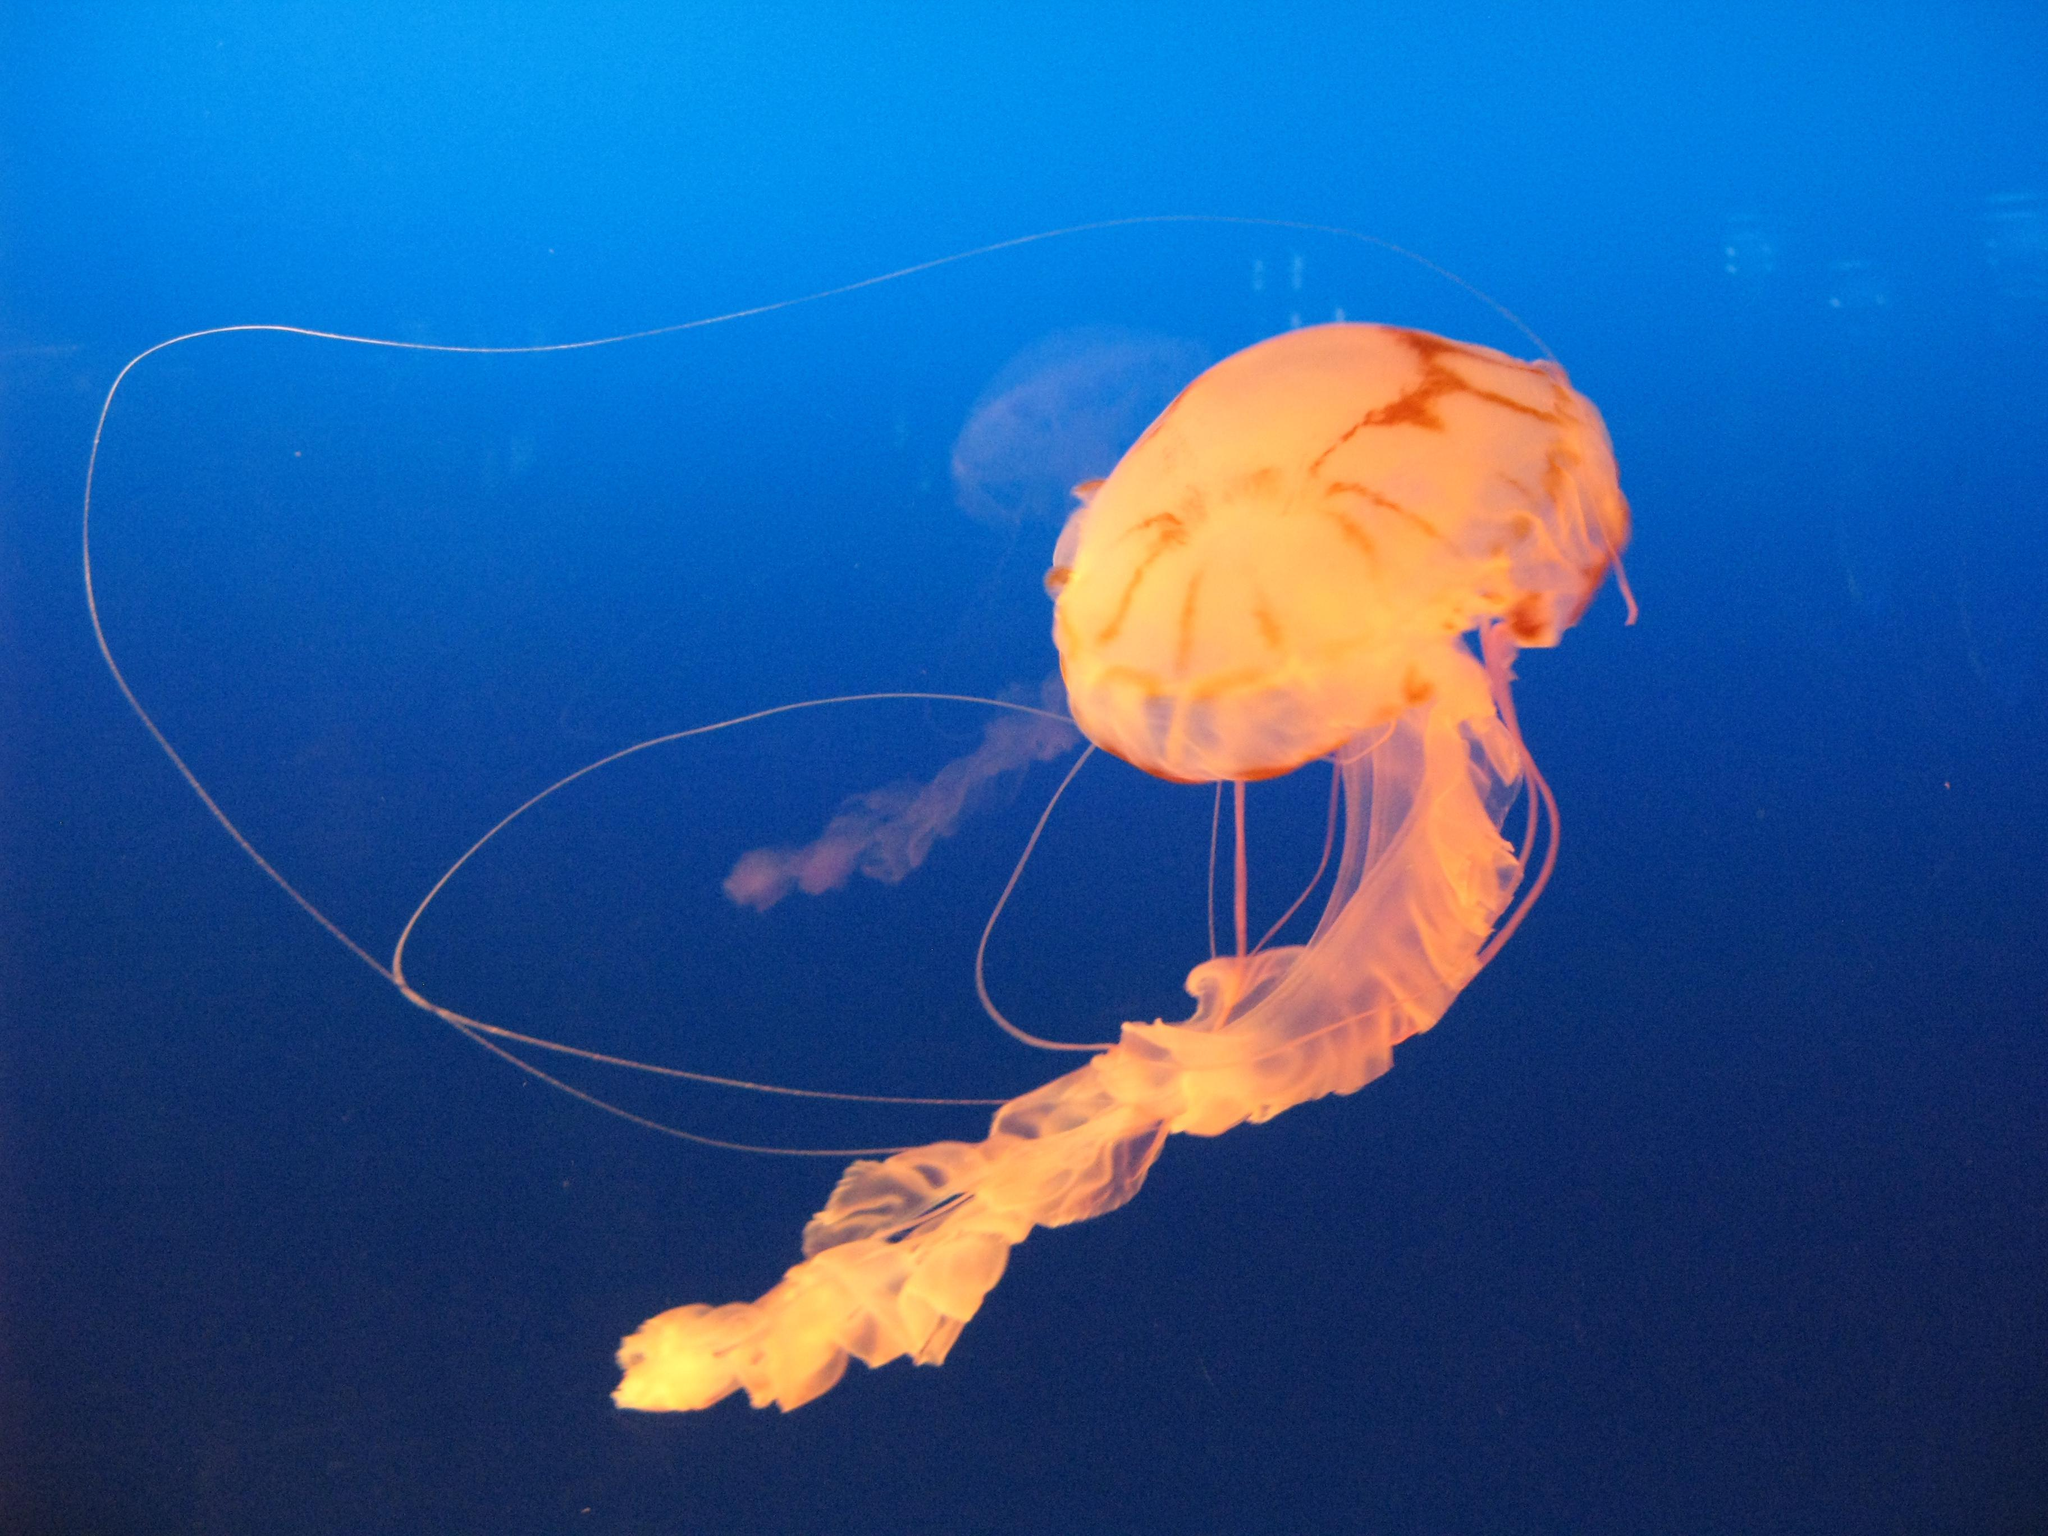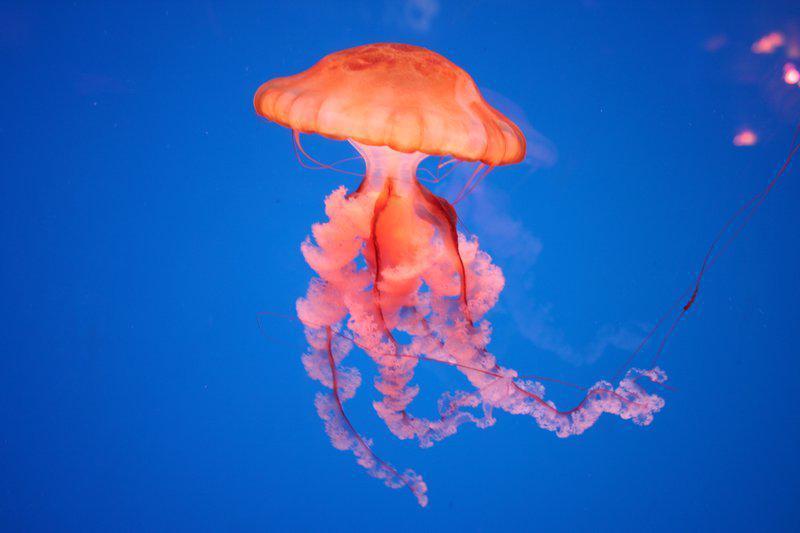The first image is the image on the left, the second image is the image on the right. Analyze the images presented: Is the assertion "One of the images shows one jellyfish with a fish inside and nothing else." valid? Answer yes or no. No. The first image is the image on the left, the second image is the image on the right. Analyze the images presented: Is the assertion "The left image includes at least one orange jellyfish with long tentacles, and the right image features a fish visible inside a translucent jellyfish." valid? Answer yes or no. No. 